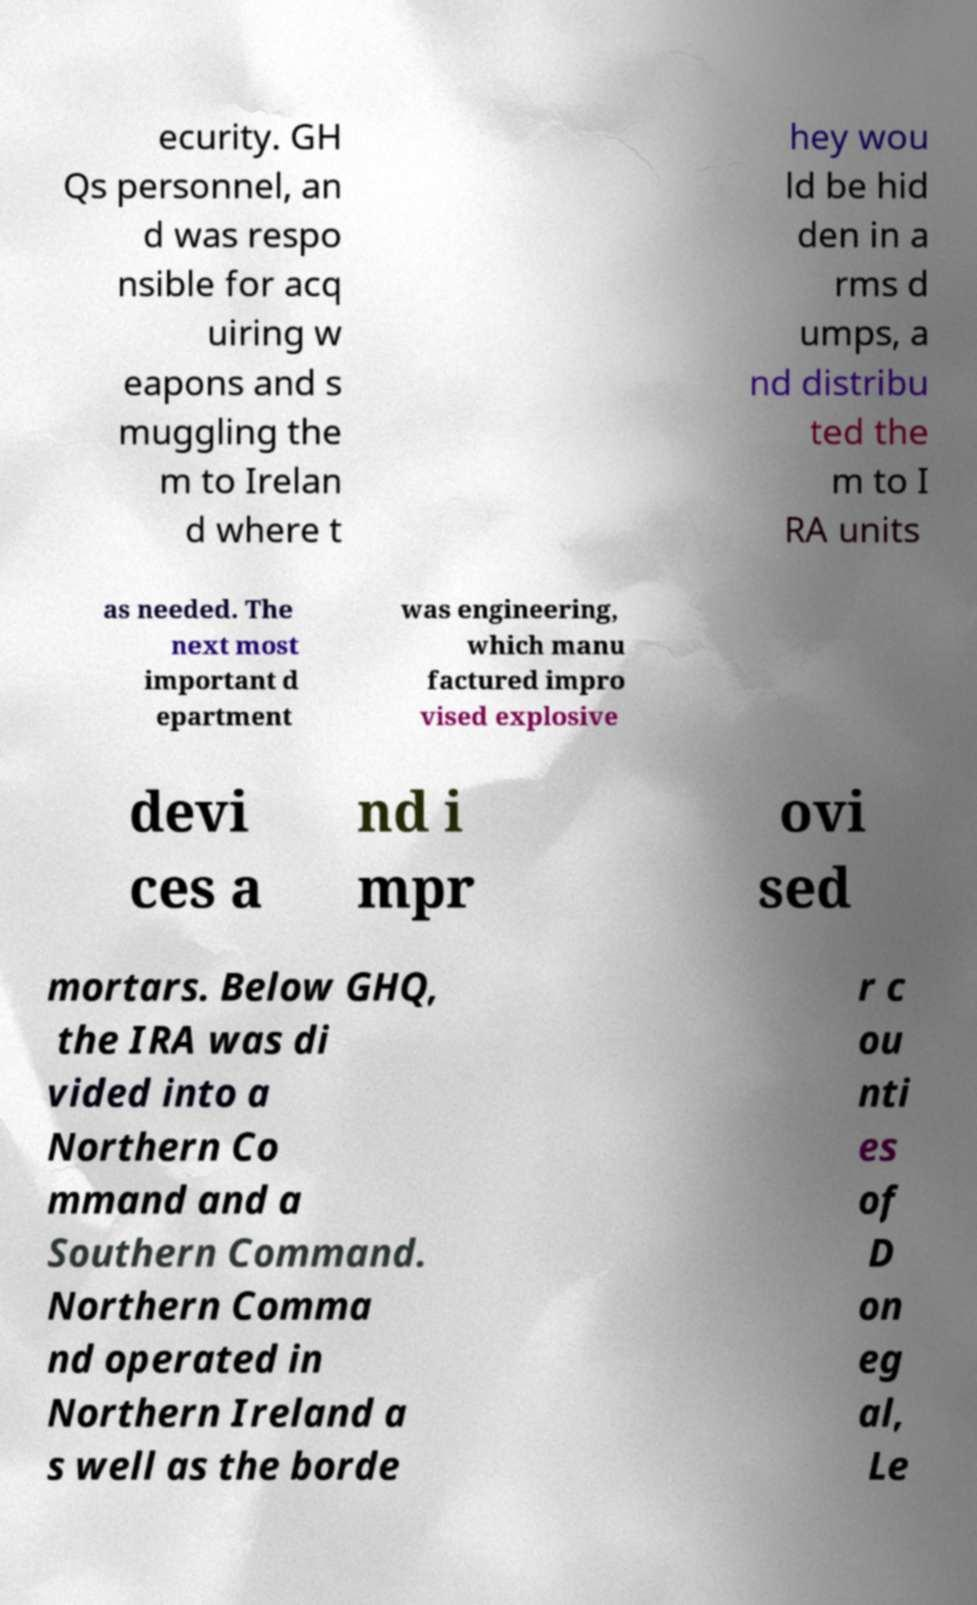Can you read and provide the text displayed in the image?This photo seems to have some interesting text. Can you extract and type it out for me? ecurity. GH Qs personnel, an d was respo nsible for acq uiring w eapons and s muggling the m to Irelan d where t hey wou ld be hid den in a rms d umps, a nd distribu ted the m to I RA units as needed. The next most important d epartment was engineering, which manu factured impro vised explosive devi ces a nd i mpr ovi sed mortars. Below GHQ, the IRA was di vided into a Northern Co mmand and a Southern Command. Northern Comma nd operated in Northern Ireland a s well as the borde r c ou nti es of D on eg al, Le 